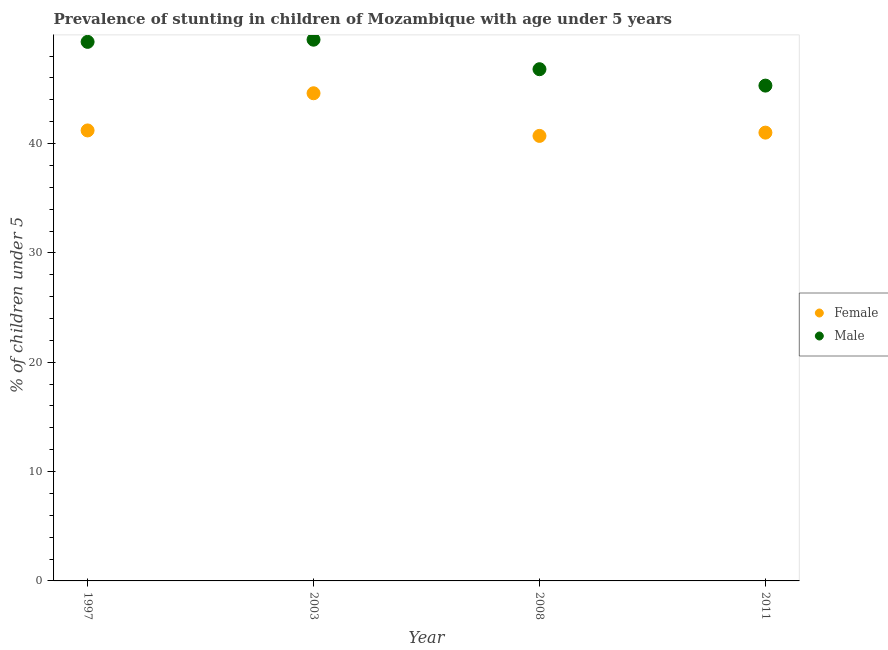How many different coloured dotlines are there?
Keep it short and to the point. 2. What is the percentage of stunted female children in 1997?
Provide a succinct answer. 41.2. Across all years, what is the maximum percentage of stunted male children?
Provide a short and direct response. 49.5. Across all years, what is the minimum percentage of stunted male children?
Provide a succinct answer. 45.3. What is the total percentage of stunted male children in the graph?
Offer a terse response. 190.9. What is the difference between the percentage of stunted male children in 2003 and that in 2008?
Make the answer very short. 2.7. What is the difference between the percentage of stunted male children in 1997 and the percentage of stunted female children in 2011?
Your response must be concise. 8.3. What is the average percentage of stunted male children per year?
Provide a short and direct response. 47.72. In the year 2008, what is the difference between the percentage of stunted female children and percentage of stunted male children?
Offer a very short reply. -6.1. What is the ratio of the percentage of stunted female children in 2003 to that in 2011?
Provide a succinct answer. 1.09. Is the percentage of stunted female children in 2003 less than that in 2011?
Keep it short and to the point. No. What is the difference between the highest and the second highest percentage of stunted female children?
Your answer should be compact. 3.4. What is the difference between the highest and the lowest percentage of stunted male children?
Keep it short and to the point. 4.2. In how many years, is the percentage of stunted female children greater than the average percentage of stunted female children taken over all years?
Your answer should be very brief. 1. Is the sum of the percentage of stunted female children in 2008 and 2011 greater than the maximum percentage of stunted male children across all years?
Your response must be concise. Yes. Is the percentage of stunted female children strictly greater than the percentage of stunted male children over the years?
Offer a very short reply. No. Is the percentage of stunted female children strictly less than the percentage of stunted male children over the years?
Offer a terse response. Yes. How many dotlines are there?
Your response must be concise. 2. How many years are there in the graph?
Your answer should be very brief. 4. Are the values on the major ticks of Y-axis written in scientific E-notation?
Offer a terse response. No. Does the graph contain any zero values?
Give a very brief answer. No. What is the title of the graph?
Your response must be concise. Prevalence of stunting in children of Mozambique with age under 5 years. What is the label or title of the Y-axis?
Make the answer very short.  % of children under 5. What is the  % of children under 5 in Female in 1997?
Give a very brief answer. 41.2. What is the  % of children under 5 of Male in 1997?
Make the answer very short. 49.3. What is the  % of children under 5 of Female in 2003?
Your answer should be compact. 44.6. What is the  % of children under 5 in Male in 2003?
Your response must be concise. 49.5. What is the  % of children under 5 of Female in 2008?
Offer a terse response. 40.7. What is the  % of children under 5 of Male in 2008?
Ensure brevity in your answer.  46.8. What is the  % of children under 5 in Female in 2011?
Ensure brevity in your answer.  41. What is the  % of children under 5 of Male in 2011?
Keep it short and to the point. 45.3. Across all years, what is the maximum  % of children under 5 of Female?
Offer a terse response. 44.6. Across all years, what is the maximum  % of children under 5 of Male?
Provide a short and direct response. 49.5. Across all years, what is the minimum  % of children under 5 in Female?
Make the answer very short. 40.7. Across all years, what is the minimum  % of children under 5 in Male?
Ensure brevity in your answer.  45.3. What is the total  % of children under 5 in Female in the graph?
Provide a succinct answer. 167.5. What is the total  % of children under 5 of Male in the graph?
Provide a short and direct response. 190.9. What is the difference between the  % of children under 5 of Female in 1997 and that in 2003?
Your response must be concise. -3.4. What is the difference between the  % of children under 5 in Female in 1997 and that in 2008?
Offer a very short reply. 0.5. What is the difference between the  % of children under 5 of Female in 1997 and that in 2011?
Your response must be concise. 0.2. What is the difference between the  % of children under 5 in Male in 2003 and that in 2011?
Keep it short and to the point. 4.2. What is the difference between the  % of children under 5 of Female in 2003 and the  % of children under 5 of Male in 2008?
Offer a terse response. -2.2. What is the difference between the  % of children under 5 in Female in 2003 and the  % of children under 5 in Male in 2011?
Provide a succinct answer. -0.7. What is the average  % of children under 5 of Female per year?
Provide a short and direct response. 41.88. What is the average  % of children under 5 in Male per year?
Your response must be concise. 47.73. In the year 2003, what is the difference between the  % of children under 5 in Female and  % of children under 5 in Male?
Give a very brief answer. -4.9. In the year 2008, what is the difference between the  % of children under 5 of Female and  % of children under 5 of Male?
Your response must be concise. -6.1. In the year 2011, what is the difference between the  % of children under 5 in Female and  % of children under 5 in Male?
Offer a very short reply. -4.3. What is the ratio of the  % of children under 5 of Female in 1997 to that in 2003?
Offer a very short reply. 0.92. What is the ratio of the  % of children under 5 of Male in 1997 to that in 2003?
Offer a very short reply. 1. What is the ratio of the  % of children under 5 of Female in 1997 to that in 2008?
Your answer should be very brief. 1.01. What is the ratio of the  % of children under 5 of Male in 1997 to that in 2008?
Offer a terse response. 1.05. What is the ratio of the  % of children under 5 in Female in 1997 to that in 2011?
Keep it short and to the point. 1. What is the ratio of the  % of children under 5 in Male in 1997 to that in 2011?
Your response must be concise. 1.09. What is the ratio of the  % of children under 5 of Female in 2003 to that in 2008?
Offer a very short reply. 1.1. What is the ratio of the  % of children under 5 in Male in 2003 to that in 2008?
Provide a short and direct response. 1.06. What is the ratio of the  % of children under 5 of Female in 2003 to that in 2011?
Ensure brevity in your answer.  1.09. What is the ratio of the  % of children under 5 in Male in 2003 to that in 2011?
Your response must be concise. 1.09. What is the ratio of the  % of children under 5 in Female in 2008 to that in 2011?
Make the answer very short. 0.99. What is the ratio of the  % of children under 5 in Male in 2008 to that in 2011?
Provide a succinct answer. 1.03. What is the difference between the highest and the second highest  % of children under 5 in Female?
Keep it short and to the point. 3.4. What is the difference between the highest and the lowest  % of children under 5 in Female?
Offer a terse response. 3.9. What is the difference between the highest and the lowest  % of children under 5 in Male?
Your response must be concise. 4.2. 